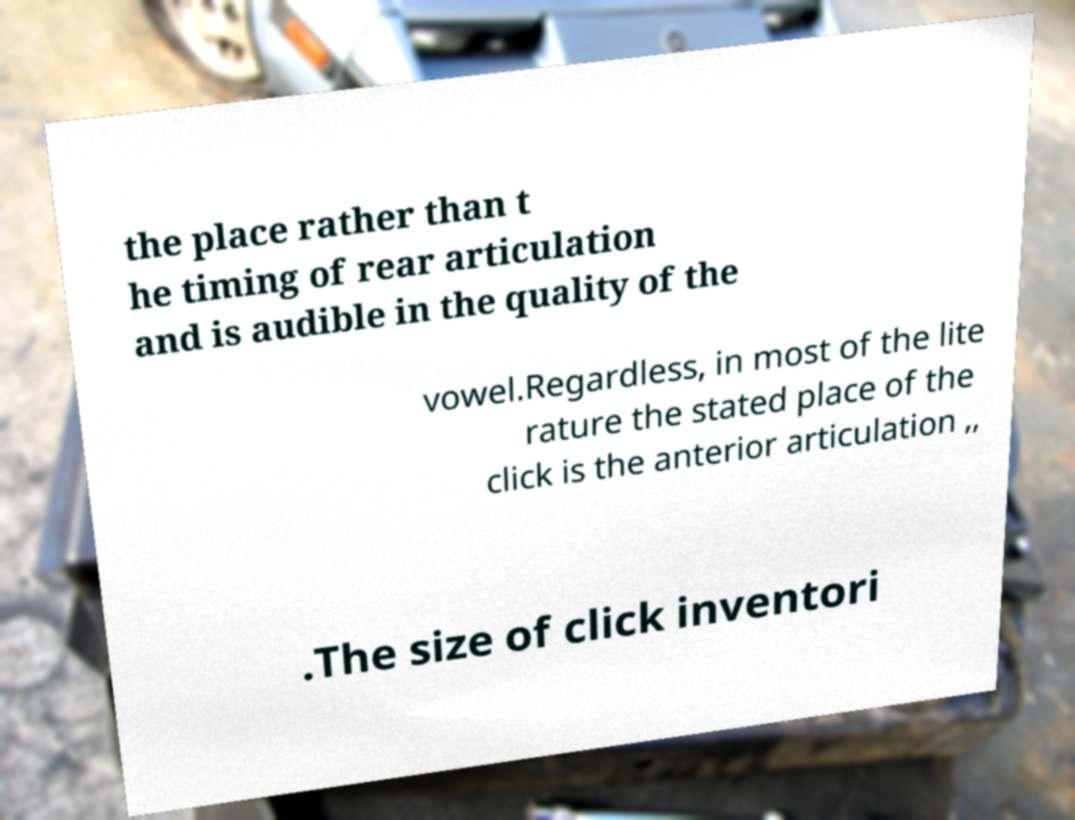Could you assist in decoding the text presented in this image and type it out clearly? the place rather than t he timing of rear articulation and is audible in the quality of the vowel.Regardless, in most of the lite rature the stated place of the click is the anterior articulation ,, .The size of click inventori 